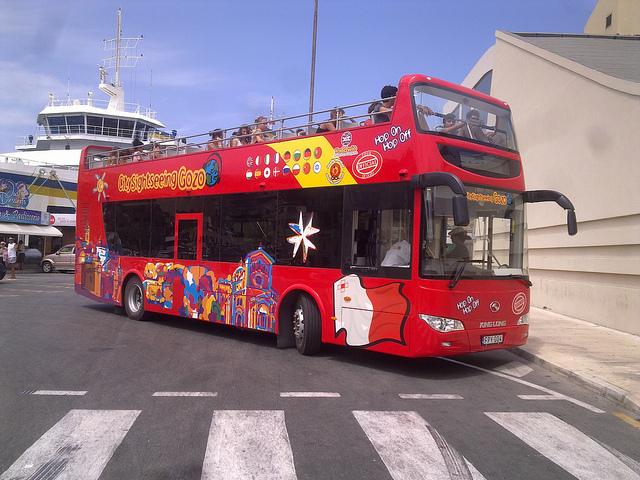Does this bus have a roof?
Give a very brief answer. No. What flag is on the bus?
Give a very brief answer. Italy. Is there a boat in the picture?
Answer briefly. Yes. 